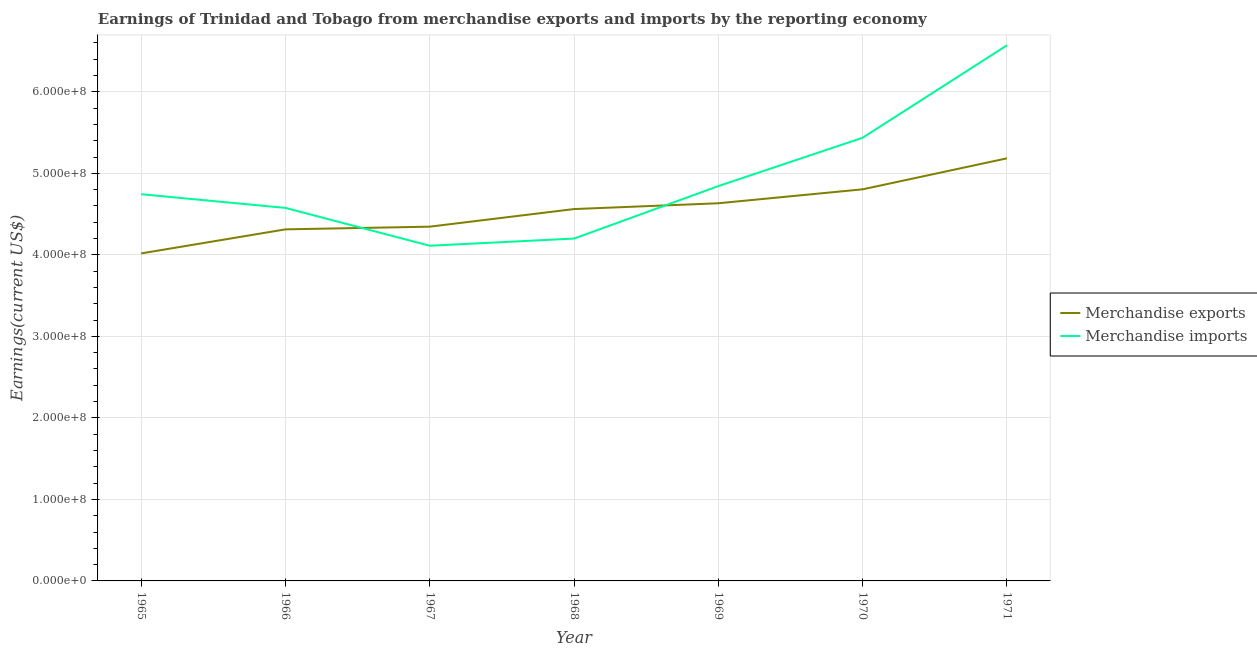What is the earnings from merchandise imports in 1966?
Provide a short and direct response. 4.58e+08. Across all years, what is the maximum earnings from merchandise exports?
Your response must be concise. 5.18e+08. Across all years, what is the minimum earnings from merchandise exports?
Keep it short and to the point. 4.02e+08. In which year was the earnings from merchandise imports maximum?
Keep it short and to the point. 1971. In which year was the earnings from merchandise exports minimum?
Make the answer very short. 1965. What is the total earnings from merchandise imports in the graph?
Ensure brevity in your answer.  3.45e+09. What is the difference between the earnings from merchandise exports in 1968 and that in 1970?
Ensure brevity in your answer.  -2.42e+07. What is the difference between the earnings from merchandise imports in 1967 and the earnings from merchandise exports in 1965?
Offer a terse response. 9.40e+06. What is the average earnings from merchandise exports per year?
Your answer should be very brief. 4.55e+08. In the year 1968, what is the difference between the earnings from merchandise exports and earnings from merchandise imports?
Your response must be concise. 3.62e+07. What is the ratio of the earnings from merchandise imports in 1965 to that in 1970?
Offer a very short reply. 0.87. What is the difference between the highest and the second highest earnings from merchandise exports?
Give a very brief answer. 3.80e+07. What is the difference between the highest and the lowest earnings from merchandise exports?
Make the answer very short. 1.17e+08. In how many years, is the earnings from merchandise exports greater than the average earnings from merchandise exports taken over all years?
Provide a short and direct response. 4. Is the sum of the earnings from merchandise exports in 1965 and 1966 greater than the maximum earnings from merchandise imports across all years?
Your answer should be very brief. Yes. Does the earnings from merchandise imports monotonically increase over the years?
Provide a short and direct response. No. Is the earnings from merchandise imports strictly less than the earnings from merchandise exports over the years?
Your answer should be very brief. No. Does the graph contain any zero values?
Provide a short and direct response. No. Where does the legend appear in the graph?
Give a very brief answer. Center right. How many legend labels are there?
Offer a terse response. 2. What is the title of the graph?
Keep it short and to the point. Earnings of Trinidad and Tobago from merchandise exports and imports by the reporting economy. What is the label or title of the X-axis?
Make the answer very short. Year. What is the label or title of the Y-axis?
Your answer should be compact. Earnings(current US$). What is the Earnings(current US$) of Merchandise exports in 1965?
Make the answer very short. 4.02e+08. What is the Earnings(current US$) in Merchandise imports in 1965?
Provide a short and direct response. 4.74e+08. What is the Earnings(current US$) in Merchandise exports in 1966?
Your answer should be very brief. 4.31e+08. What is the Earnings(current US$) of Merchandise imports in 1966?
Ensure brevity in your answer.  4.58e+08. What is the Earnings(current US$) of Merchandise exports in 1967?
Give a very brief answer. 4.35e+08. What is the Earnings(current US$) in Merchandise imports in 1967?
Your answer should be very brief. 4.11e+08. What is the Earnings(current US$) of Merchandise exports in 1968?
Keep it short and to the point. 4.56e+08. What is the Earnings(current US$) of Merchandise imports in 1968?
Keep it short and to the point. 4.20e+08. What is the Earnings(current US$) in Merchandise exports in 1969?
Make the answer very short. 4.63e+08. What is the Earnings(current US$) in Merchandise imports in 1969?
Your answer should be compact. 4.84e+08. What is the Earnings(current US$) of Merchandise exports in 1970?
Provide a succinct answer. 4.80e+08. What is the Earnings(current US$) in Merchandise imports in 1970?
Make the answer very short. 5.44e+08. What is the Earnings(current US$) in Merchandise exports in 1971?
Offer a terse response. 5.18e+08. What is the Earnings(current US$) in Merchandise imports in 1971?
Offer a very short reply. 6.57e+08. Across all years, what is the maximum Earnings(current US$) in Merchandise exports?
Provide a succinct answer. 5.18e+08. Across all years, what is the maximum Earnings(current US$) in Merchandise imports?
Offer a terse response. 6.57e+08. Across all years, what is the minimum Earnings(current US$) in Merchandise exports?
Provide a short and direct response. 4.02e+08. Across all years, what is the minimum Earnings(current US$) of Merchandise imports?
Your response must be concise. 4.11e+08. What is the total Earnings(current US$) in Merchandise exports in the graph?
Offer a very short reply. 3.19e+09. What is the total Earnings(current US$) of Merchandise imports in the graph?
Ensure brevity in your answer.  3.45e+09. What is the difference between the Earnings(current US$) of Merchandise exports in 1965 and that in 1966?
Offer a terse response. -2.95e+07. What is the difference between the Earnings(current US$) in Merchandise imports in 1965 and that in 1966?
Offer a very short reply. 1.68e+07. What is the difference between the Earnings(current US$) in Merchandise exports in 1965 and that in 1967?
Offer a very short reply. -3.28e+07. What is the difference between the Earnings(current US$) in Merchandise imports in 1965 and that in 1967?
Provide a short and direct response. 6.32e+07. What is the difference between the Earnings(current US$) of Merchandise exports in 1965 and that in 1968?
Your answer should be compact. -5.44e+07. What is the difference between the Earnings(current US$) of Merchandise imports in 1965 and that in 1968?
Offer a very short reply. 5.44e+07. What is the difference between the Earnings(current US$) of Merchandise exports in 1965 and that in 1969?
Offer a very short reply. -6.15e+07. What is the difference between the Earnings(current US$) in Merchandise imports in 1965 and that in 1969?
Your answer should be compact. -9.97e+06. What is the difference between the Earnings(current US$) of Merchandise exports in 1965 and that in 1970?
Keep it short and to the point. -7.86e+07. What is the difference between the Earnings(current US$) in Merchandise imports in 1965 and that in 1970?
Offer a very short reply. -6.93e+07. What is the difference between the Earnings(current US$) of Merchandise exports in 1965 and that in 1971?
Provide a short and direct response. -1.17e+08. What is the difference between the Earnings(current US$) in Merchandise imports in 1965 and that in 1971?
Offer a terse response. -1.83e+08. What is the difference between the Earnings(current US$) in Merchandise exports in 1966 and that in 1967?
Provide a short and direct response. -3.30e+06. What is the difference between the Earnings(current US$) in Merchandise imports in 1966 and that in 1967?
Give a very brief answer. 4.64e+07. What is the difference between the Earnings(current US$) of Merchandise exports in 1966 and that in 1968?
Provide a succinct answer. -2.49e+07. What is the difference between the Earnings(current US$) in Merchandise imports in 1966 and that in 1968?
Offer a very short reply. 3.76e+07. What is the difference between the Earnings(current US$) of Merchandise exports in 1966 and that in 1969?
Make the answer very short. -3.20e+07. What is the difference between the Earnings(current US$) of Merchandise imports in 1966 and that in 1969?
Your answer should be compact. -2.68e+07. What is the difference between the Earnings(current US$) of Merchandise exports in 1966 and that in 1970?
Ensure brevity in your answer.  -4.91e+07. What is the difference between the Earnings(current US$) in Merchandise imports in 1966 and that in 1970?
Offer a terse response. -8.61e+07. What is the difference between the Earnings(current US$) of Merchandise exports in 1966 and that in 1971?
Keep it short and to the point. -8.71e+07. What is the difference between the Earnings(current US$) of Merchandise imports in 1966 and that in 1971?
Provide a short and direct response. -2.00e+08. What is the difference between the Earnings(current US$) of Merchandise exports in 1967 and that in 1968?
Keep it short and to the point. -2.16e+07. What is the difference between the Earnings(current US$) of Merchandise imports in 1967 and that in 1968?
Your answer should be compact. -8.80e+06. What is the difference between the Earnings(current US$) in Merchandise exports in 1967 and that in 1969?
Your answer should be compact. -2.87e+07. What is the difference between the Earnings(current US$) in Merchandise imports in 1967 and that in 1969?
Offer a terse response. -7.32e+07. What is the difference between the Earnings(current US$) of Merchandise exports in 1967 and that in 1970?
Your answer should be compact. -4.58e+07. What is the difference between the Earnings(current US$) in Merchandise imports in 1967 and that in 1970?
Give a very brief answer. -1.33e+08. What is the difference between the Earnings(current US$) in Merchandise exports in 1967 and that in 1971?
Your answer should be very brief. -8.38e+07. What is the difference between the Earnings(current US$) in Merchandise imports in 1967 and that in 1971?
Provide a succinct answer. -2.46e+08. What is the difference between the Earnings(current US$) in Merchandise exports in 1968 and that in 1969?
Your answer should be very brief. -7.11e+06. What is the difference between the Earnings(current US$) of Merchandise imports in 1968 and that in 1969?
Provide a succinct answer. -6.44e+07. What is the difference between the Earnings(current US$) of Merchandise exports in 1968 and that in 1970?
Your answer should be compact. -2.42e+07. What is the difference between the Earnings(current US$) in Merchandise imports in 1968 and that in 1970?
Keep it short and to the point. -1.24e+08. What is the difference between the Earnings(current US$) of Merchandise exports in 1968 and that in 1971?
Give a very brief answer. -6.22e+07. What is the difference between the Earnings(current US$) of Merchandise imports in 1968 and that in 1971?
Keep it short and to the point. -2.37e+08. What is the difference between the Earnings(current US$) of Merchandise exports in 1969 and that in 1970?
Provide a succinct answer. -1.71e+07. What is the difference between the Earnings(current US$) in Merchandise imports in 1969 and that in 1970?
Offer a terse response. -5.93e+07. What is the difference between the Earnings(current US$) of Merchandise exports in 1969 and that in 1971?
Offer a very short reply. -5.51e+07. What is the difference between the Earnings(current US$) of Merchandise imports in 1969 and that in 1971?
Offer a terse response. -1.73e+08. What is the difference between the Earnings(current US$) of Merchandise exports in 1970 and that in 1971?
Give a very brief answer. -3.80e+07. What is the difference between the Earnings(current US$) in Merchandise imports in 1970 and that in 1971?
Ensure brevity in your answer.  -1.13e+08. What is the difference between the Earnings(current US$) of Merchandise exports in 1965 and the Earnings(current US$) of Merchandise imports in 1966?
Make the answer very short. -5.58e+07. What is the difference between the Earnings(current US$) of Merchandise exports in 1965 and the Earnings(current US$) of Merchandise imports in 1967?
Your response must be concise. -9.40e+06. What is the difference between the Earnings(current US$) of Merchandise exports in 1965 and the Earnings(current US$) of Merchandise imports in 1968?
Provide a succinct answer. -1.82e+07. What is the difference between the Earnings(current US$) in Merchandise exports in 1965 and the Earnings(current US$) in Merchandise imports in 1969?
Provide a short and direct response. -8.26e+07. What is the difference between the Earnings(current US$) of Merchandise exports in 1965 and the Earnings(current US$) of Merchandise imports in 1970?
Provide a succinct answer. -1.42e+08. What is the difference between the Earnings(current US$) of Merchandise exports in 1965 and the Earnings(current US$) of Merchandise imports in 1971?
Provide a short and direct response. -2.55e+08. What is the difference between the Earnings(current US$) in Merchandise exports in 1966 and the Earnings(current US$) in Merchandise imports in 1967?
Give a very brief answer. 2.01e+07. What is the difference between the Earnings(current US$) in Merchandise exports in 1966 and the Earnings(current US$) in Merchandise imports in 1968?
Keep it short and to the point. 1.13e+07. What is the difference between the Earnings(current US$) of Merchandise exports in 1966 and the Earnings(current US$) of Merchandise imports in 1969?
Give a very brief answer. -5.31e+07. What is the difference between the Earnings(current US$) in Merchandise exports in 1966 and the Earnings(current US$) in Merchandise imports in 1970?
Provide a short and direct response. -1.12e+08. What is the difference between the Earnings(current US$) of Merchandise exports in 1966 and the Earnings(current US$) of Merchandise imports in 1971?
Your response must be concise. -2.26e+08. What is the difference between the Earnings(current US$) in Merchandise exports in 1967 and the Earnings(current US$) in Merchandise imports in 1968?
Ensure brevity in your answer.  1.46e+07. What is the difference between the Earnings(current US$) in Merchandise exports in 1967 and the Earnings(current US$) in Merchandise imports in 1969?
Your answer should be very brief. -4.98e+07. What is the difference between the Earnings(current US$) of Merchandise exports in 1967 and the Earnings(current US$) of Merchandise imports in 1970?
Your answer should be very brief. -1.09e+08. What is the difference between the Earnings(current US$) of Merchandise exports in 1967 and the Earnings(current US$) of Merchandise imports in 1971?
Keep it short and to the point. -2.23e+08. What is the difference between the Earnings(current US$) in Merchandise exports in 1968 and the Earnings(current US$) in Merchandise imports in 1969?
Provide a short and direct response. -2.82e+07. What is the difference between the Earnings(current US$) of Merchandise exports in 1968 and the Earnings(current US$) of Merchandise imports in 1970?
Provide a succinct answer. -8.75e+07. What is the difference between the Earnings(current US$) in Merchandise exports in 1968 and the Earnings(current US$) in Merchandise imports in 1971?
Your answer should be compact. -2.01e+08. What is the difference between the Earnings(current US$) of Merchandise exports in 1969 and the Earnings(current US$) of Merchandise imports in 1970?
Your response must be concise. -8.04e+07. What is the difference between the Earnings(current US$) of Merchandise exports in 1969 and the Earnings(current US$) of Merchandise imports in 1971?
Make the answer very short. -1.94e+08. What is the difference between the Earnings(current US$) of Merchandise exports in 1970 and the Earnings(current US$) of Merchandise imports in 1971?
Make the answer very short. -1.77e+08. What is the average Earnings(current US$) in Merchandise exports per year?
Provide a succinct answer. 4.55e+08. What is the average Earnings(current US$) in Merchandise imports per year?
Your answer should be very brief. 4.93e+08. In the year 1965, what is the difference between the Earnings(current US$) of Merchandise exports and Earnings(current US$) of Merchandise imports?
Your answer should be compact. -7.26e+07. In the year 1966, what is the difference between the Earnings(current US$) of Merchandise exports and Earnings(current US$) of Merchandise imports?
Ensure brevity in your answer.  -2.63e+07. In the year 1967, what is the difference between the Earnings(current US$) in Merchandise exports and Earnings(current US$) in Merchandise imports?
Offer a very short reply. 2.34e+07. In the year 1968, what is the difference between the Earnings(current US$) of Merchandise exports and Earnings(current US$) of Merchandise imports?
Offer a terse response. 3.62e+07. In the year 1969, what is the difference between the Earnings(current US$) of Merchandise exports and Earnings(current US$) of Merchandise imports?
Ensure brevity in your answer.  -2.11e+07. In the year 1970, what is the difference between the Earnings(current US$) of Merchandise exports and Earnings(current US$) of Merchandise imports?
Offer a terse response. -6.33e+07. In the year 1971, what is the difference between the Earnings(current US$) of Merchandise exports and Earnings(current US$) of Merchandise imports?
Give a very brief answer. -1.39e+08. What is the ratio of the Earnings(current US$) of Merchandise exports in 1965 to that in 1966?
Provide a short and direct response. 0.93. What is the ratio of the Earnings(current US$) of Merchandise imports in 1965 to that in 1966?
Offer a very short reply. 1.04. What is the ratio of the Earnings(current US$) of Merchandise exports in 1965 to that in 1967?
Provide a short and direct response. 0.92. What is the ratio of the Earnings(current US$) in Merchandise imports in 1965 to that in 1967?
Provide a short and direct response. 1.15. What is the ratio of the Earnings(current US$) of Merchandise exports in 1965 to that in 1968?
Provide a succinct answer. 0.88. What is the ratio of the Earnings(current US$) in Merchandise imports in 1965 to that in 1968?
Provide a short and direct response. 1.13. What is the ratio of the Earnings(current US$) of Merchandise exports in 1965 to that in 1969?
Offer a terse response. 0.87. What is the ratio of the Earnings(current US$) of Merchandise imports in 1965 to that in 1969?
Give a very brief answer. 0.98. What is the ratio of the Earnings(current US$) of Merchandise exports in 1965 to that in 1970?
Ensure brevity in your answer.  0.84. What is the ratio of the Earnings(current US$) in Merchandise imports in 1965 to that in 1970?
Your answer should be compact. 0.87. What is the ratio of the Earnings(current US$) of Merchandise exports in 1965 to that in 1971?
Your answer should be very brief. 0.78. What is the ratio of the Earnings(current US$) of Merchandise imports in 1965 to that in 1971?
Your answer should be very brief. 0.72. What is the ratio of the Earnings(current US$) in Merchandise exports in 1966 to that in 1967?
Keep it short and to the point. 0.99. What is the ratio of the Earnings(current US$) in Merchandise imports in 1966 to that in 1967?
Offer a very short reply. 1.11. What is the ratio of the Earnings(current US$) in Merchandise exports in 1966 to that in 1968?
Make the answer very short. 0.95. What is the ratio of the Earnings(current US$) in Merchandise imports in 1966 to that in 1968?
Offer a terse response. 1.09. What is the ratio of the Earnings(current US$) of Merchandise exports in 1966 to that in 1969?
Provide a short and direct response. 0.93. What is the ratio of the Earnings(current US$) in Merchandise imports in 1966 to that in 1969?
Keep it short and to the point. 0.94. What is the ratio of the Earnings(current US$) of Merchandise exports in 1966 to that in 1970?
Your answer should be compact. 0.9. What is the ratio of the Earnings(current US$) of Merchandise imports in 1966 to that in 1970?
Provide a succinct answer. 0.84. What is the ratio of the Earnings(current US$) in Merchandise exports in 1966 to that in 1971?
Offer a very short reply. 0.83. What is the ratio of the Earnings(current US$) of Merchandise imports in 1966 to that in 1971?
Keep it short and to the point. 0.7. What is the ratio of the Earnings(current US$) in Merchandise exports in 1967 to that in 1968?
Your response must be concise. 0.95. What is the ratio of the Earnings(current US$) in Merchandise imports in 1967 to that in 1968?
Ensure brevity in your answer.  0.98. What is the ratio of the Earnings(current US$) of Merchandise exports in 1967 to that in 1969?
Make the answer very short. 0.94. What is the ratio of the Earnings(current US$) in Merchandise imports in 1967 to that in 1969?
Offer a very short reply. 0.85. What is the ratio of the Earnings(current US$) in Merchandise exports in 1967 to that in 1970?
Provide a succinct answer. 0.9. What is the ratio of the Earnings(current US$) of Merchandise imports in 1967 to that in 1970?
Provide a short and direct response. 0.76. What is the ratio of the Earnings(current US$) of Merchandise exports in 1967 to that in 1971?
Ensure brevity in your answer.  0.84. What is the ratio of the Earnings(current US$) of Merchandise imports in 1967 to that in 1971?
Offer a terse response. 0.63. What is the ratio of the Earnings(current US$) in Merchandise exports in 1968 to that in 1969?
Ensure brevity in your answer.  0.98. What is the ratio of the Earnings(current US$) in Merchandise imports in 1968 to that in 1969?
Your answer should be compact. 0.87. What is the ratio of the Earnings(current US$) in Merchandise exports in 1968 to that in 1970?
Ensure brevity in your answer.  0.95. What is the ratio of the Earnings(current US$) in Merchandise imports in 1968 to that in 1970?
Make the answer very short. 0.77. What is the ratio of the Earnings(current US$) of Merchandise exports in 1968 to that in 1971?
Offer a terse response. 0.88. What is the ratio of the Earnings(current US$) in Merchandise imports in 1968 to that in 1971?
Your answer should be compact. 0.64. What is the ratio of the Earnings(current US$) in Merchandise exports in 1969 to that in 1970?
Offer a terse response. 0.96. What is the ratio of the Earnings(current US$) of Merchandise imports in 1969 to that in 1970?
Make the answer very short. 0.89. What is the ratio of the Earnings(current US$) of Merchandise exports in 1969 to that in 1971?
Ensure brevity in your answer.  0.89. What is the ratio of the Earnings(current US$) in Merchandise imports in 1969 to that in 1971?
Make the answer very short. 0.74. What is the ratio of the Earnings(current US$) of Merchandise exports in 1970 to that in 1971?
Your answer should be compact. 0.93. What is the ratio of the Earnings(current US$) in Merchandise imports in 1970 to that in 1971?
Provide a short and direct response. 0.83. What is the difference between the highest and the second highest Earnings(current US$) of Merchandise exports?
Keep it short and to the point. 3.80e+07. What is the difference between the highest and the second highest Earnings(current US$) in Merchandise imports?
Offer a terse response. 1.13e+08. What is the difference between the highest and the lowest Earnings(current US$) of Merchandise exports?
Provide a succinct answer. 1.17e+08. What is the difference between the highest and the lowest Earnings(current US$) of Merchandise imports?
Make the answer very short. 2.46e+08. 